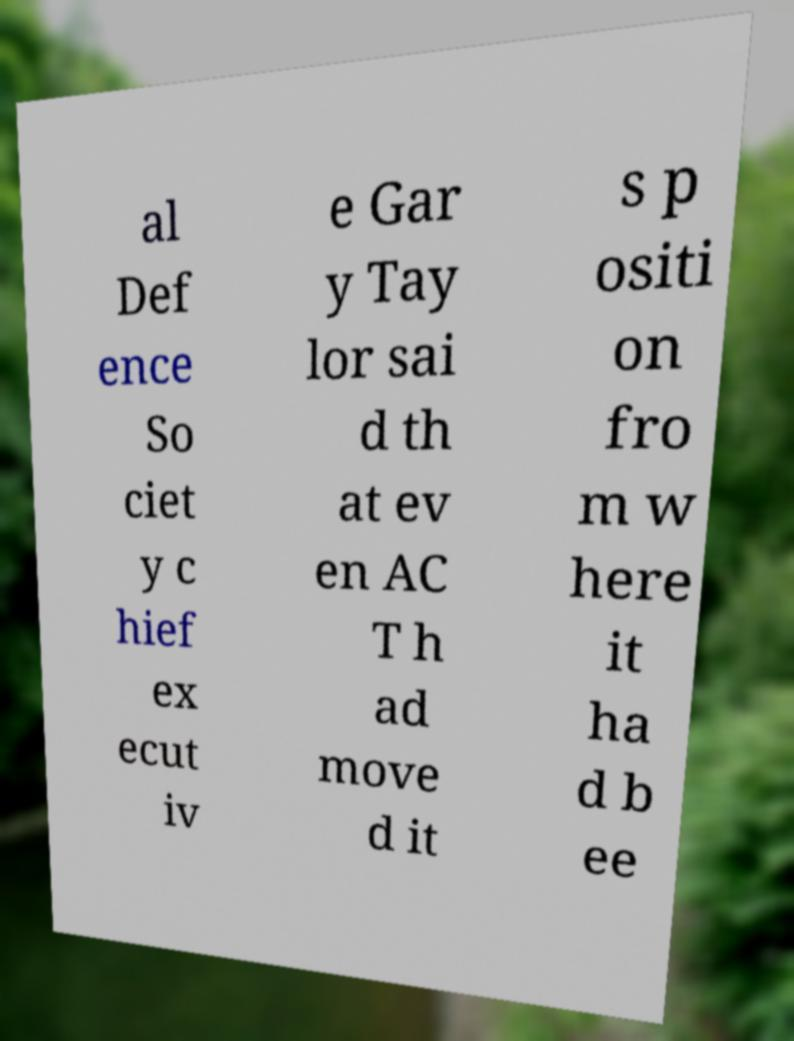Please identify and transcribe the text found in this image. al Def ence So ciet y c hief ex ecut iv e Gar y Tay lor sai d th at ev en AC T h ad move d it s p ositi on fro m w here it ha d b ee 